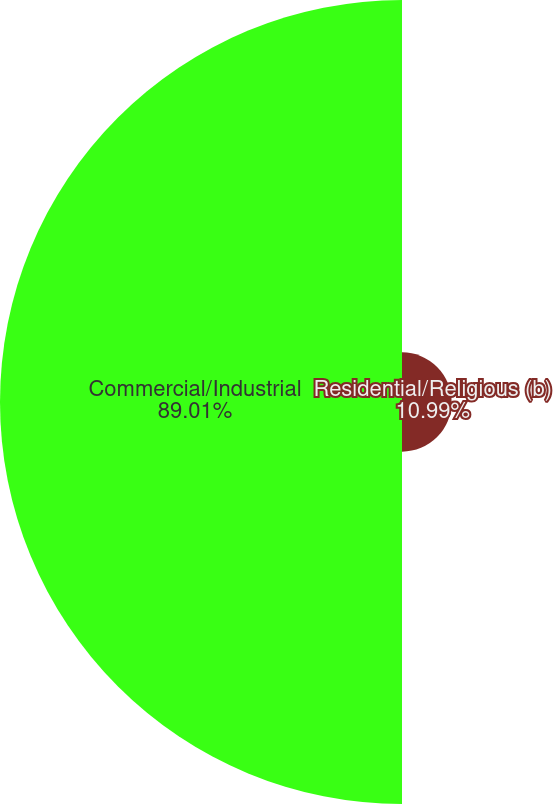<chart> <loc_0><loc_0><loc_500><loc_500><pie_chart><fcel>Residential/Religious (b)<fcel>Commercial/Industrial<nl><fcel>10.99%<fcel>89.01%<nl></chart> 